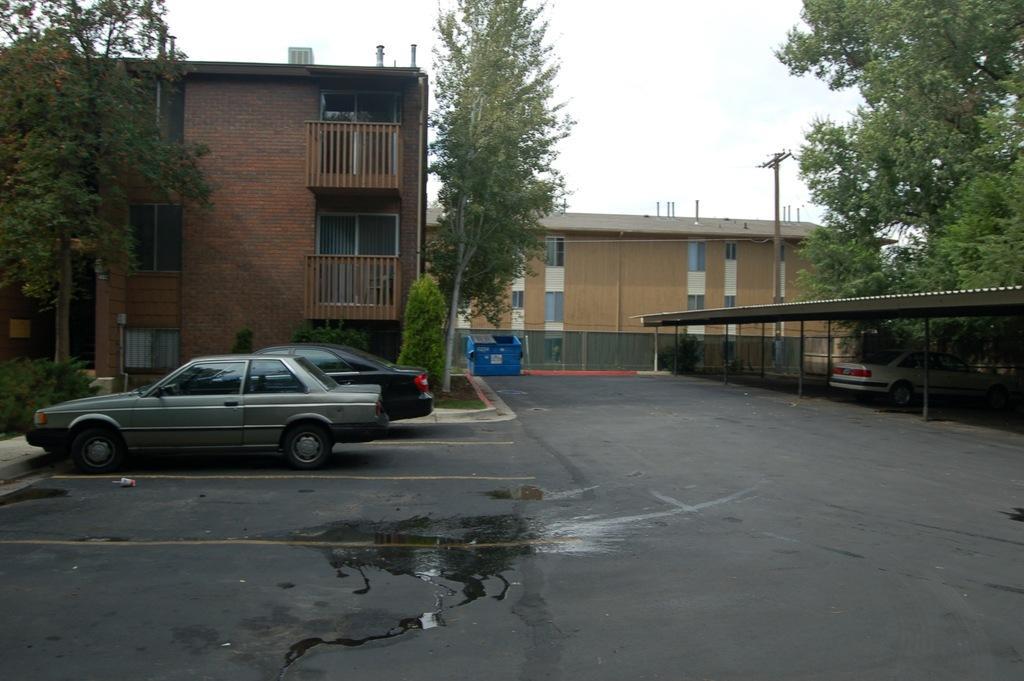Please provide a concise description of this image. In this image I can see the ground, some water on the ground, two cars which are black and grey in color on the ground. In the background I can see the shed, a car under the shed, few poles, few buildings which are brown and cream in color, few trees and the sky. 